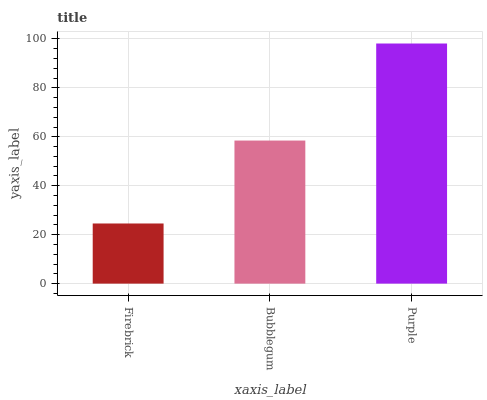Is Firebrick the minimum?
Answer yes or no. Yes. Is Purple the maximum?
Answer yes or no. Yes. Is Bubblegum the minimum?
Answer yes or no. No. Is Bubblegum the maximum?
Answer yes or no. No. Is Bubblegum greater than Firebrick?
Answer yes or no. Yes. Is Firebrick less than Bubblegum?
Answer yes or no. Yes. Is Firebrick greater than Bubblegum?
Answer yes or no. No. Is Bubblegum less than Firebrick?
Answer yes or no. No. Is Bubblegum the high median?
Answer yes or no. Yes. Is Bubblegum the low median?
Answer yes or no. Yes. Is Firebrick the high median?
Answer yes or no. No. Is Firebrick the low median?
Answer yes or no. No. 